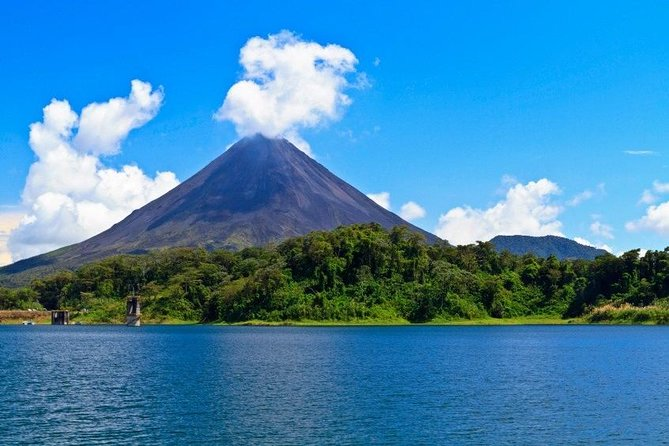What is this photo about? This captivating photo showcases the Arenal Volcano, located in the verdant rainforests of Costa Rica. With its distinctive conical shape, the volcano is one of the most active and picturesque in Central America, rising majestically above the surrounding landscape. The foreground of the photo features the tranquil Arenal Lake, reflecting the sky above. This volcanic region, shrouded in lush tropical forest, is a hotspot for biodiversity and attracts nature enthusiasts and adventure seekers worldwide. The vivid blue sky with soft cloud patterns accentuates the volcano's prominence in the region and highlights its importance as both a natural wonder and a crucial ecosystem. 